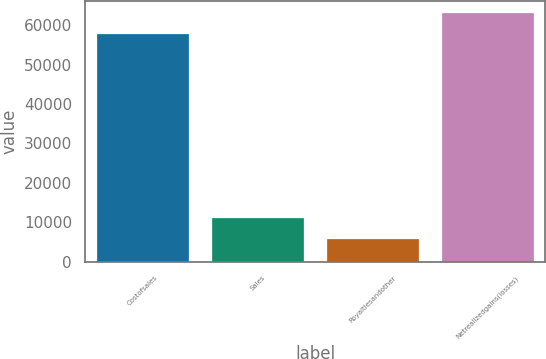Convert chart. <chart><loc_0><loc_0><loc_500><loc_500><bar_chart><fcel>Costofsales<fcel>Sales<fcel>Royaltiesandother<fcel>Netrealizedgains(losses)<nl><fcel>57786<fcel>11146.1<fcel>5776<fcel>63156.1<nl></chart> 